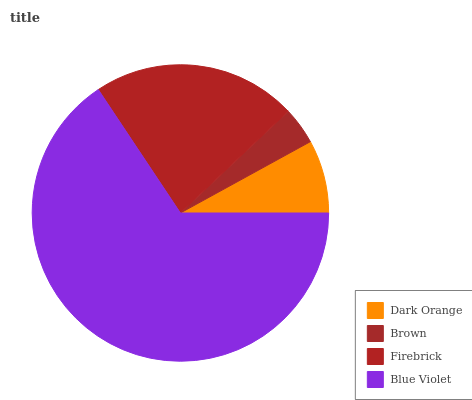Is Brown the minimum?
Answer yes or no. Yes. Is Blue Violet the maximum?
Answer yes or no. Yes. Is Firebrick the minimum?
Answer yes or no. No. Is Firebrick the maximum?
Answer yes or no. No. Is Firebrick greater than Brown?
Answer yes or no. Yes. Is Brown less than Firebrick?
Answer yes or no. Yes. Is Brown greater than Firebrick?
Answer yes or no. No. Is Firebrick less than Brown?
Answer yes or no. No. Is Firebrick the high median?
Answer yes or no. Yes. Is Dark Orange the low median?
Answer yes or no. Yes. Is Dark Orange the high median?
Answer yes or no. No. Is Brown the low median?
Answer yes or no. No. 